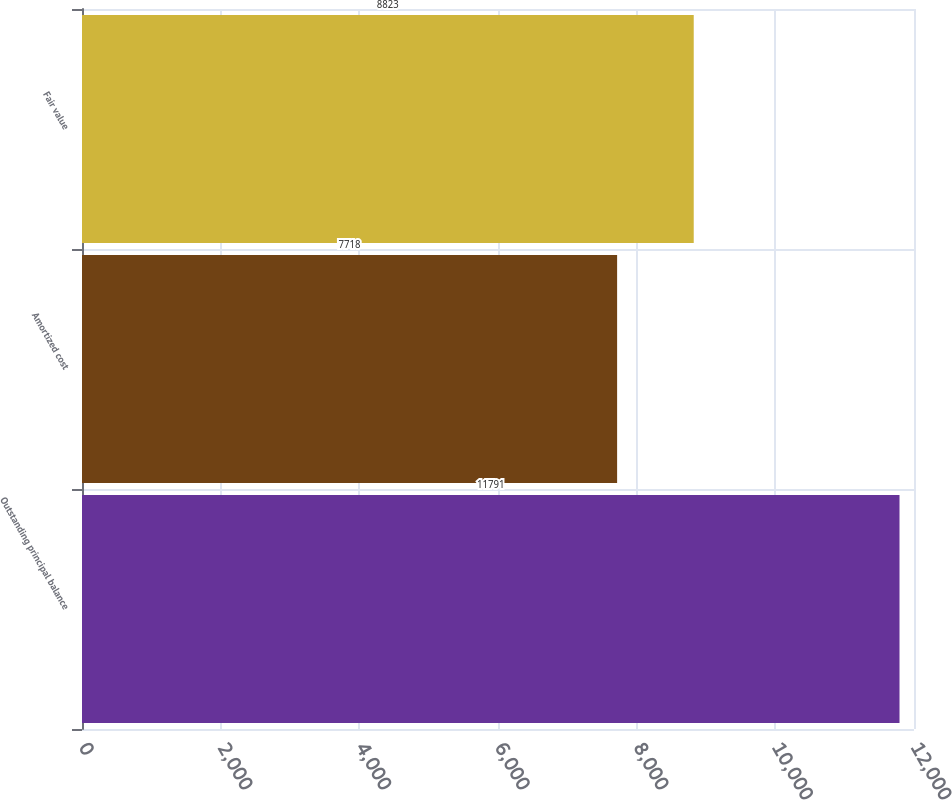Convert chart. <chart><loc_0><loc_0><loc_500><loc_500><bar_chart><fcel>Outstanding principal balance<fcel>Amortized cost<fcel>Fair value<nl><fcel>11791<fcel>7718<fcel>8823<nl></chart> 